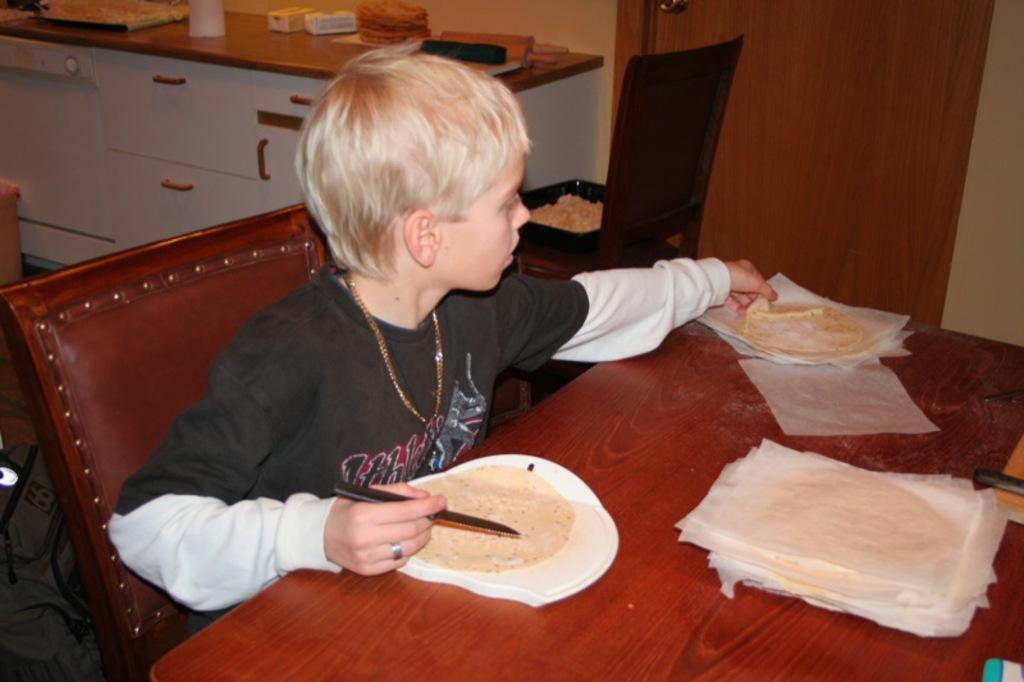Please provide a concise description of this image. In this picture I can observe a boy sitting on the chair in front of a table. I can observe food placed on the table. In the background I can observe few things placed on the desk. 